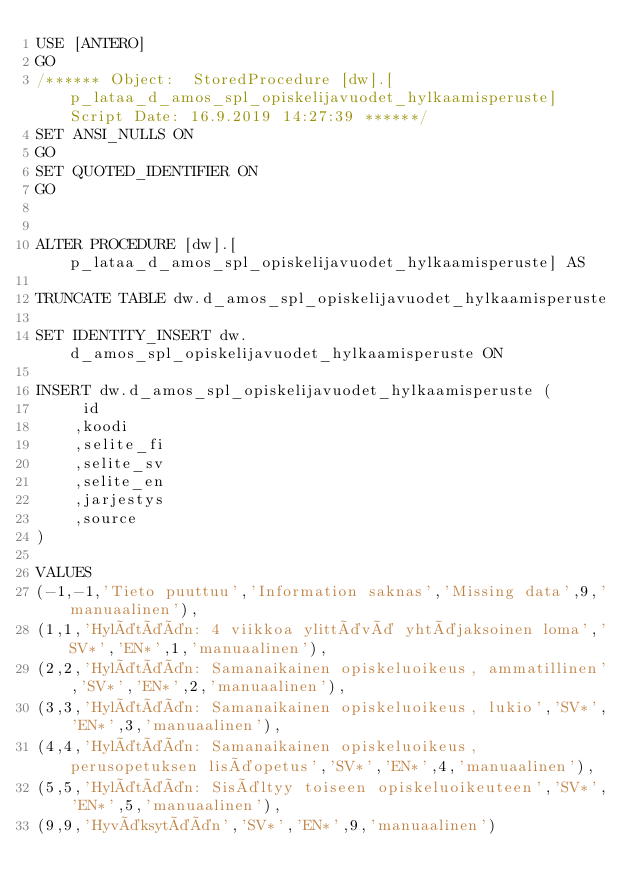<code> <loc_0><loc_0><loc_500><loc_500><_SQL_>USE [ANTERO]
GO
/****** Object:  StoredProcedure [dw].[p_lataa_d_amos_spl_opiskelijavuodet_hylkaamisperuste]    Script Date: 16.9.2019 14:27:39 ******/
SET ANSI_NULLS ON
GO
SET QUOTED_IDENTIFIER ON
GO


ALTER PROCEDURE [dw].[p_lataa_d_amos_spl_opiskelijavuodet_hylkaamisperuste] AS

TRUNCATE TABLE dw.d_amos_spl_opiskelijavuodet_hylkaamisperuste

SET IDENTITY_INSERT dw.d_amos_spl_opiskelijavuodet_hylkaamisperuste ON

INSERT dw.d_amos_spl_opiskelijavuodet_hylkaamisperuste (
	 id
	,koodi
	,selite_fi
	,selite_sv
	,selite_en
	,jarjestys
	,source
)

VALUES 
(-1,-1,'Tieto puuttuu','Information saknas','Missing data',9,'manuaalinen'),
(1,1,'Hylätään: 4 viikkoa ylittävä yhtäjaksoinen loma','SV*','EN*',1,'manuaalinen'),
(2,2,'Hylätään: Samanaikainen opiskeluoikeus, ammatillinen','SV*','EN*',2,'manuaalinen'),
(3,3,'Hylätään: Samanaikainen opiskeluoikeus, lukio','SV*','EN*',3,'manuaalinen'),
(4,4,'Hylätään: Samanaikainen opiskeluoikeus, perusopetuksen lisäopetus','SV*','EN*',4,'manuaalinen'),
(5,5,'Hylätään: Sisältyy toiseen opiskeluoikeuteen','SV*','EN*',5,'manuaalinen'),
(9,9,'Hyväksytään','SV*','EN*',9,'manuaalinen')
</code> 